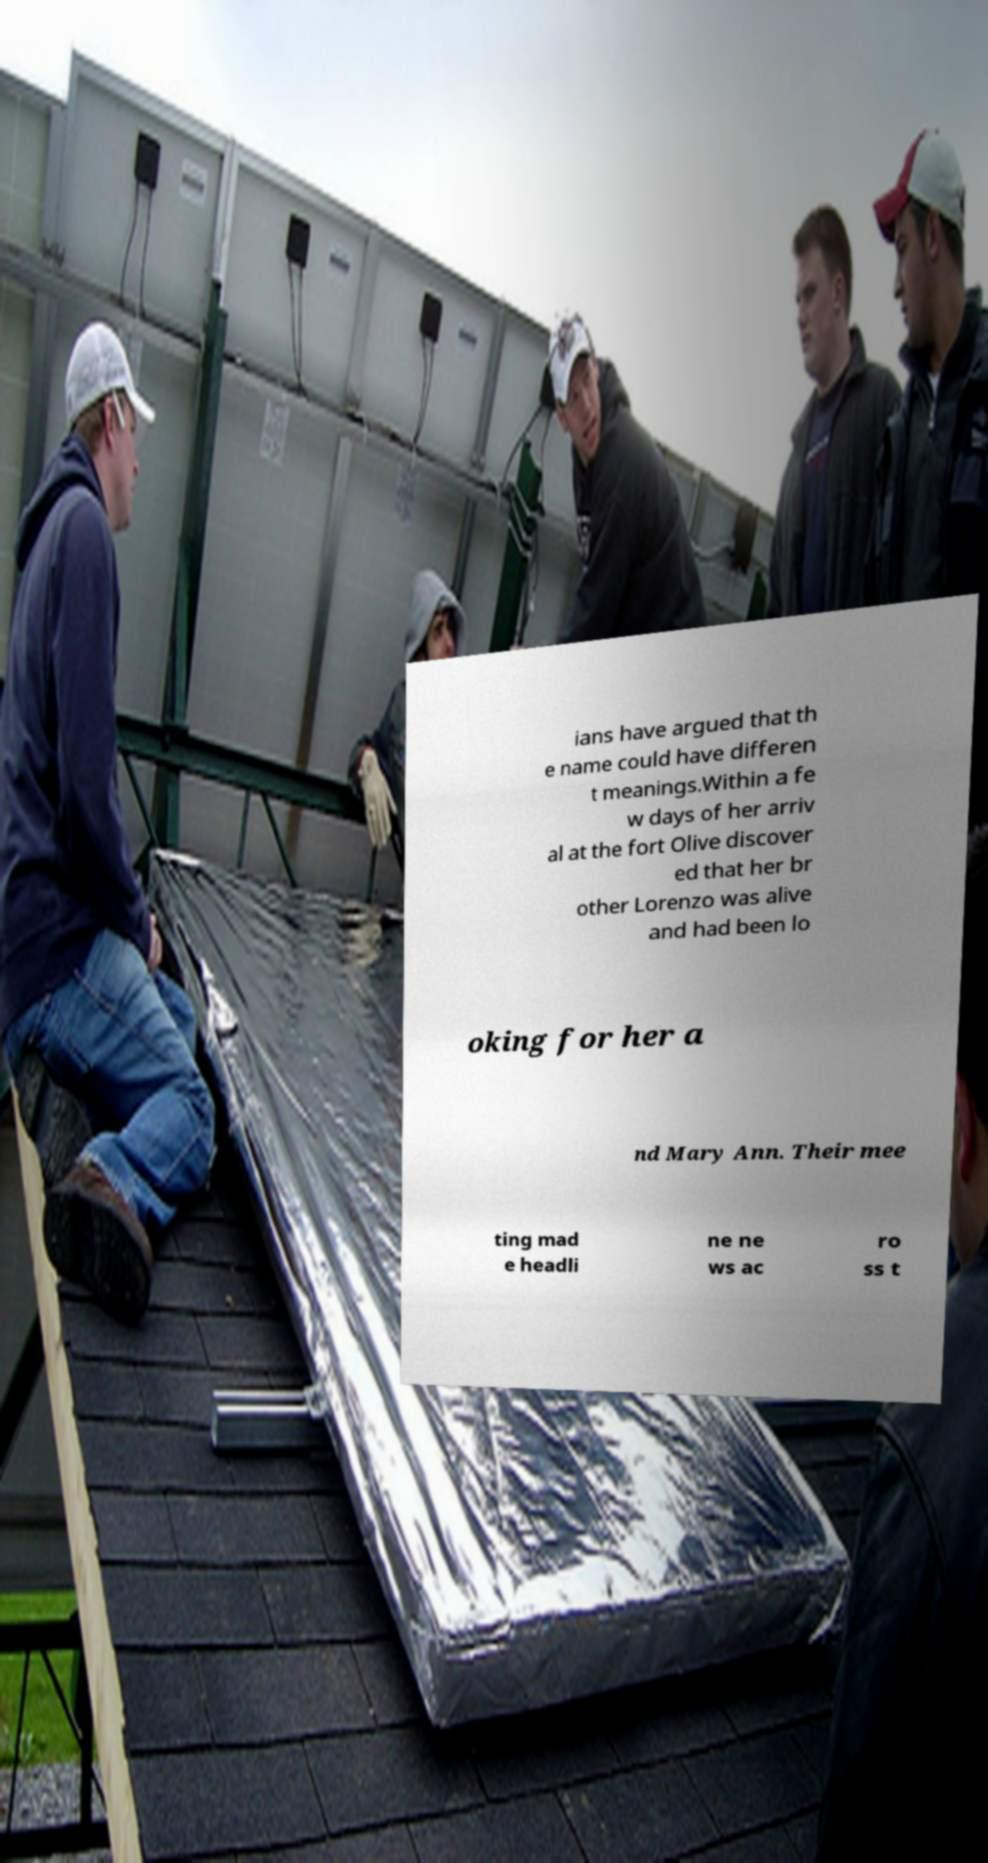For documentation purposes, I need the text within this image transcribed. Could you provide that? ians have argued that th e name could have differen t meanings.Within a fe w days of her arriv al at the fort Olive discover ed that her br other Lorenzo was alive and had been lo oking for her a nd Mary Ann. Their mee ting mad e headli ne ne ws ac ro ss t 